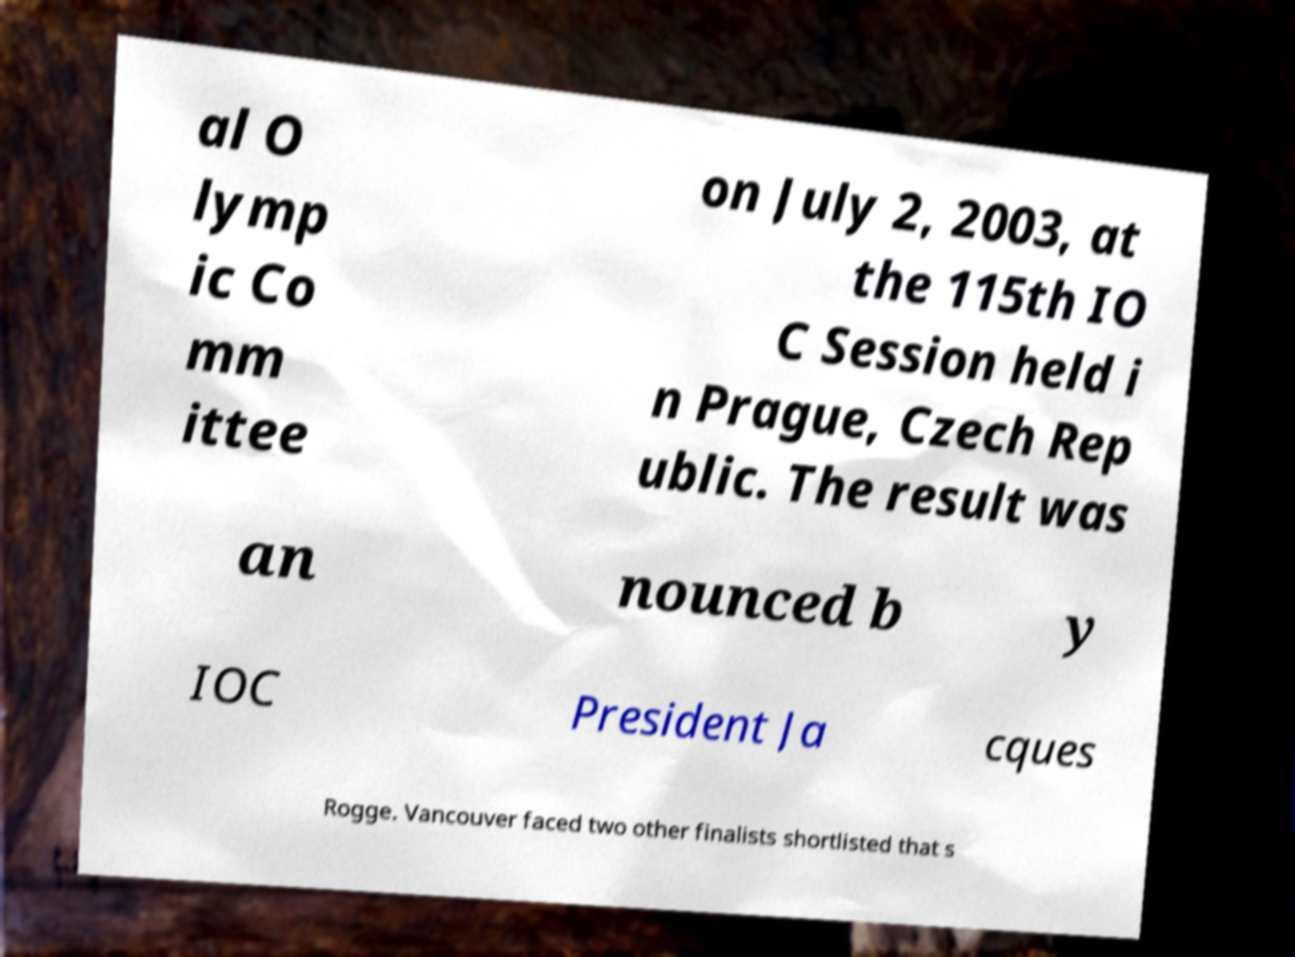For documentation purposes, I need the text within this image transcribed. Could you provide that? al O lymp ic Co mm ittee on July 2, 2003, at the 115th IO C Session held i n Prague, Czech Rep ublic. The result was an nounced b y IOC President Ja cques Rogge. Vancouver faced two other finalists shortlisted that s 